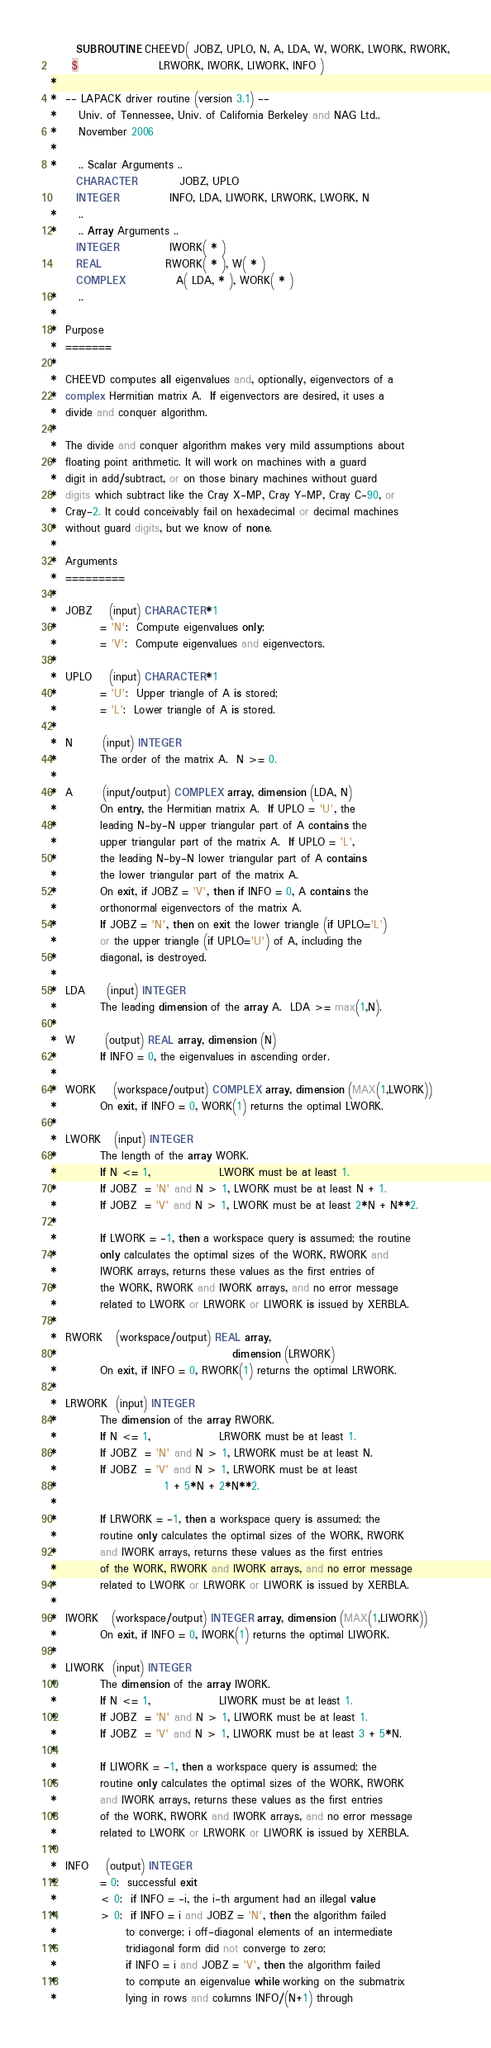<code> <loc_0><loc_0><loc_500><loc_500><_FORTRAN_>      SUBROUTINE CHEEVD( JOBZ, UPLO, N, A, LDA, W, WORK, LWORK, RWORK,
     $                   LRWORK, IWORK, LIWORK, INFO )
*
*  -- LAPACK driver routine (version 3.1) --
*     Univ. of Tennessee, Univ. of California Berkeley and NAG Ltd..
*     November 2006
*
*     .. Scalar Arguments ..
      CHARACTER          JOBZ, UPLO
      INTEGER            INFO, LDA, LIWORK, LRWORK, LWORK, N
*     ..
*     .. Array Arguments ..
      INTEGER            IWORK( * )
      REAL               RWORK( * ), W( * )
      COMPLEX            A( LDA, * ), WORK( * )
*     ..
*
*  Purpose
*  =======
*
*  CHEEVD computes all eigenvalues and, optionally, eigenvectors of a
*  complex Hermitian matrix A.  If eigenvectors are desired, it uses a
*  divide and conquer algorithm.
*
*  The divide and conquer algorithm makes very mild assumptions about
*  floating point arithmetic. It will work on machines with a guard
*  digit in add/subtract, or on those binary machines without guard
*  digits which subtract like the Cray X-MP, Cray Y-MP, Cray C-90, or
*  Cray-2. It could conceivably fail on hexadecimal or decimal machines
*  without guard digits, but we know of none.
*
*  Arguments
*  =========
*
*  JOBZ    (input) CHARACTER*1
*          = 'N':  Compute eigenvalues only;
*          = 'V':  Compute eigenvalues and eigenvectors.
*
*  UPLO    (input) CHARACTER*1
*          = 'U':  Upper triangle of A is stored;
*          = 'L':  Lower triangle of A is stored.
*
*  N       (input) INTEGER
*          The order of the matrix A.  N >= 0.
*
*  A       (input/output) COMPLEX array, dimension (LDA, N)
*          On entry, the Hermitian matrix A.  If UPLO = 'U', the
*          leading N-by-N upper triangular part of A contains the
*          upper triangular part of the matrix A.  If UPLO = 'L',
*          the leading N-by-N lower triangular part of A contains
*          the lower triangular part of the matrix A.
*          On exit, if JOBZ = 'V', then if INFO = 0, A contains the
*          orthonormal eigenvectors of the matrix A.
*          If JOBZ = 'N', then on exit the lower triangle (if UPLO='L')
*          or the upper triangle (if UPLO='U') of A, including the
*          diagonal, is destroyed.
*
*  LDA     (input) INTEGER
*          The leading dimension of the array A.  LDA >= max(1,N).
*
*  W       (output) REAL array, dimension (N)
*          If INFO = 0, the eigenvalues in ascending order.
*
*  WORK    (workspace/output) COMPLEX array, dimension (MAX(1,LWORK))
*          On exit, if INFO = 0, WORK(1) returns the optimal LWORK.
*
*  LWORK   (input) INTEGER
*          The length of the array WORK.
*          If N <= 1,                LWORK must be at least 1.
*          If JOBZ  = 'N' and N > 1, LWORK must be at least N + 1.
*          If JOBZ  = 'V' and N > 1, LWORK must be at least 2*N + N**2.
*
*          If LWORK = -1, then a workspace query is assumed; the routine
*          only calculates the optimal sizes of the WORK, RWORK and
*          IWORK arrays, returns these values as the first entries of
*          the WORK, RWORK and IWORK arrays, and no error message
*          related to LWORK or LRWORK or LIWORK is issued by XERBLA.
*
*  RWORK   (workspace/output) REAL array,
*                                         dimension (LRWORK)
*          On exit, if INFO = 0, RWORK(1) returns the optimal LRWORK.
*
*  LRWORK  (input) INTEGER
*          The dimension of the array RWORK.
*          If N <= 1,                LRWORK must be at least 1.
*          If JOBZ  = 'N' and N > 1, LRWORK must be at least N.
*          If JOBZ  = 'V' and N > 1, LRWORK must be at least
*                         1 + 5*N + 2*N**2.
*
*          If LRWORK = -1, then a workspace query is assumed; the
*          routine only calculates the optimal sizes of the WORK, RWORK
*          and IWORK arrays, returns these values as the first entries
*          of the WORK, RWORK and IWORK arrays, and no error message
*          related to LWORK or LRWORK or LIWORK is issued by XERBLA.
*
*  IWORK   (workspace/output) INTEGER array, dimension (MAX(1,LIWORK))
*          On exit, if INFO = 0, IWORK(1) returns the optimal LIWORK.
*
*  LIWORK  (input) INTEGER
*          The dimension of the array IWORK.
*          If N <= 1,                LIWORK must be at least 1.
*          If JOBZ  = 'N' and N > 1, LIWORK must be at least 1.
*          If JOBZ  = 'V' and N > 1, LIWORK must be at least 3 + 5*N.
*
*          If LIWORK = -1, then a workspace query is assumed; the
*          routine only calculates the optimal sizes of the WORK, RWORK
*          and IWORK arrays, returns these values as the first entries
*          of the WORK, RWORK and IWORK arrays, and no error message
*          related to LWORK or LRWORK or LIWORK is issued by XERBLA.
*
*  INFO    (output) INTEGER
*          = 0:  successful exit
*          < 0:  if INFO = -i, the i-th argument had an illegal value
*          > 0:  if INFO = i and JOBZ = 'N', then the algorithm failed
*                to converge; i off-diagonal elements of an intermediate
*                tridiagonal form did not converge to zero;
*                if INFO = i and JOBZ = 'V', then the algorithm failed
*                to compute an eigenvalue while working on the submatrix
*                lying in rows and columns INFO/(N+1) through</code> 